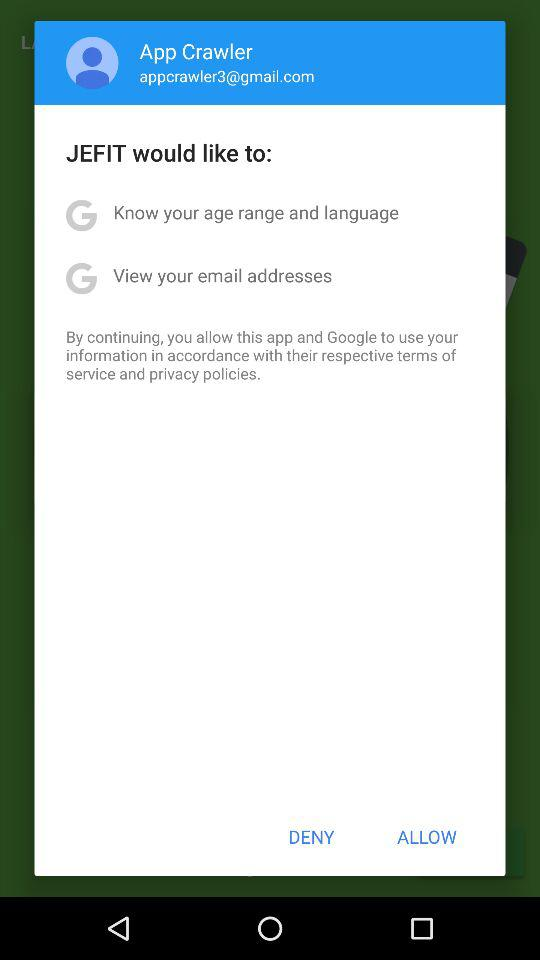What application is asking for permission to know the age range, language and email addresses? The application asking for permission is "JEFIT". 